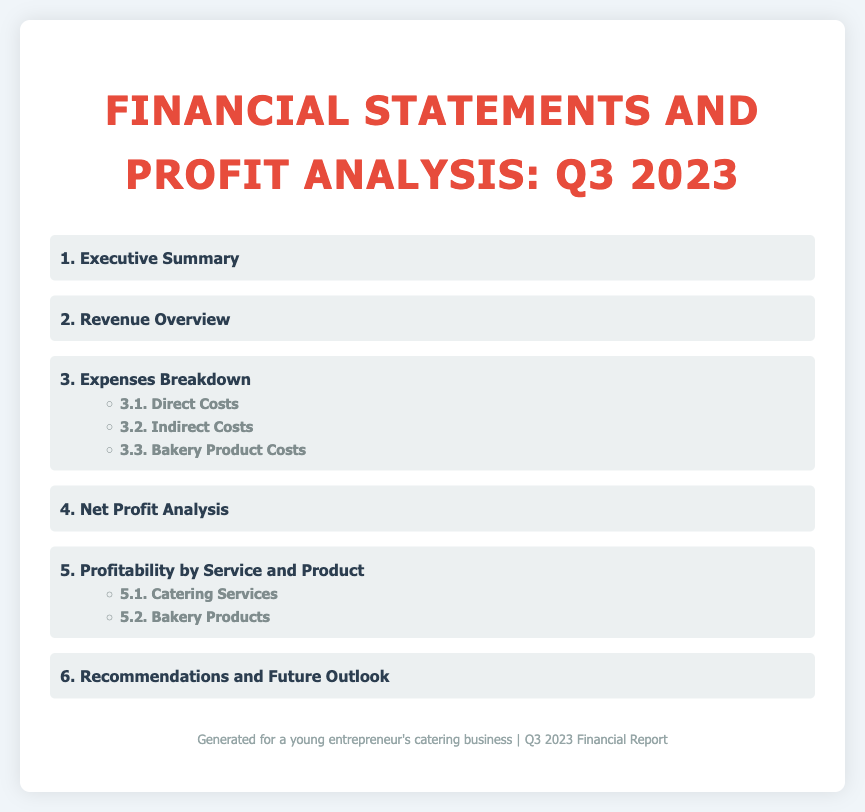What is the title of the document? The title of the document is specified in the header section of the HTML, stating "Financial Statements and Profit Analysis: Q3 2023."
Answer: Financial Statements and Profit Analysis: Q3 2023 What is the first section of the index? The first section of the index is listed as "1. Executive Summary."
Answer: Executive Summary What section discusses expenses? The section that discusses expenses is titled "3. Expenses Breakdown."
Answer: 3. Expenses Breakdown Which sub-section addresses bakery product costs? The sub-section that addresses bakery product costs is "3.3. Bakery Product Costs."
Answer: 3.3. Bakery Product Costs How many main sections are listed in the index? The index lists a total of six main sections, as numbered from 1 to 6.
Answer: 6 Which section follows the Net Profit Analysis? The section that follows the Net Profit Analysis is "5. Profitability by Service and Product."
Answer: 5. Profitability by Service and Product What is the focus of section 5 in the index? Section 5 focuses on the profitability by specific services and bakery products.
Answer: Profitability by Service and Product What is mentioned in the footer of the document? The footer of the document mentions that it is generated for a young entrepreneur's catering business and indicates the time frame as Q3 2023 Financial Report.
Answer: Q3 2023 Financial Report Which two types of profitability are specifically analyzed in section 5? Section 5 analyzes profitability regarding "Catering Services" and "Bakery Products."
Answer: Catering Services and Bakery Products 